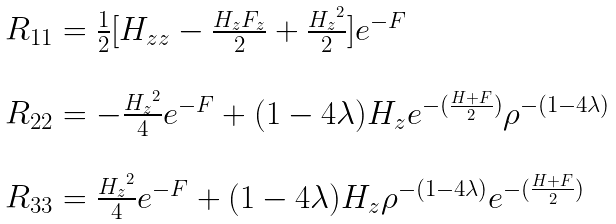<formula> <loc_0><loc_0><loc_500><loc_500>\begin{array} { l l l } R _ { 1 1 } = \frac { 1 } { 2 } [ H _ { z z } - \frac { H _ { z } F _ { z } } { 2 } + \frac { { { H } _ { z } } ^ { 2 } } { 2 } ] e ^ { - F } \\ \\ R _ { 2 2 } = - \frac { { H _ { z } } ^ { 2 } } { 4 } e ^ { - F } + ( 1 - 4 { \lambda } ) H _ { z } e ^ { - ( \frac { H + F } { 2 } ) } { \rho } ^ { - ( 1 - 4 { \lambda } ) } \\ \\ R _ { 3 3 } = \frac { { H _ { z } } ^ { 2 } } { 4 } e ^ { - F } + ( 1 - 4 { \lambda } ) H _ { z } { \rho } ^ { - ( 1 - 4 { \lambda } ) } e ^ { - ( \frac { H + F } { 2 } ) } \end{array}</formula> 